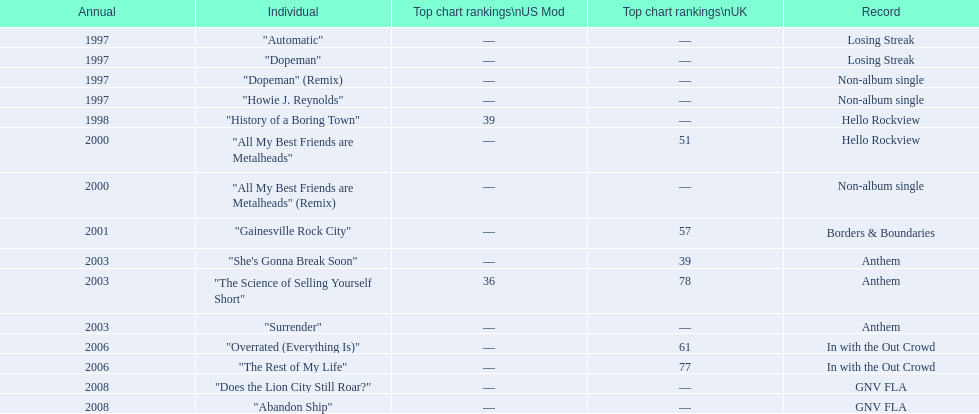What was the average chart position of their singles in the uk? 60.5. 